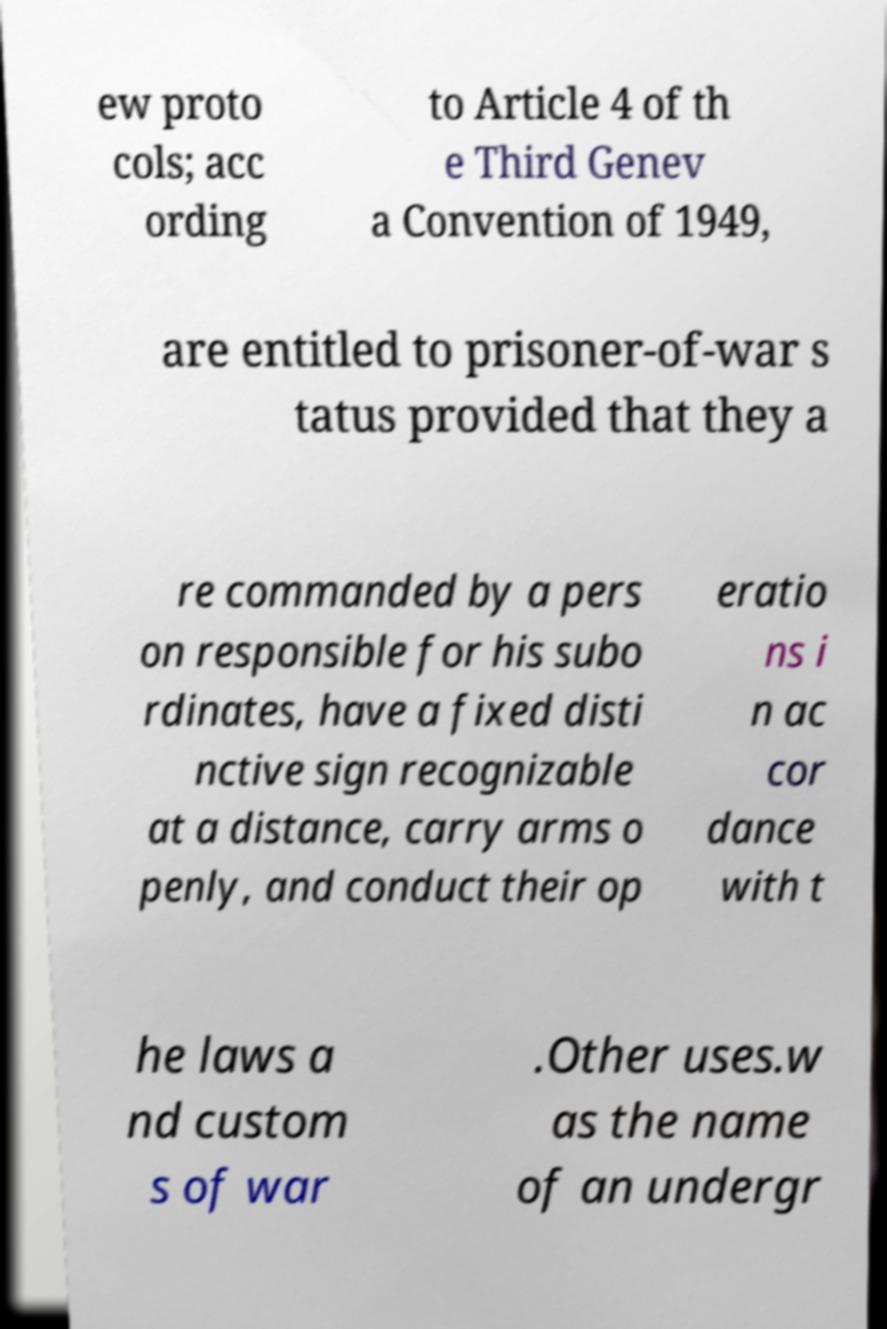Please identify and transcribe the text found in this image. ew proto cols; acc ording to Article 4 of th e Third Genev a Convention of 1949, are entitled to prisoner-of-war s tatus provided that they a re commanded by a pers on responsible for his subo rdinates, have a fixed disti nctive sign recognizable at a distance, carry arms o penly, and conduct their op eratio ns i n ac cor dance with t he laws a nd custom s of war .Other uses.w as the name of an undergr 